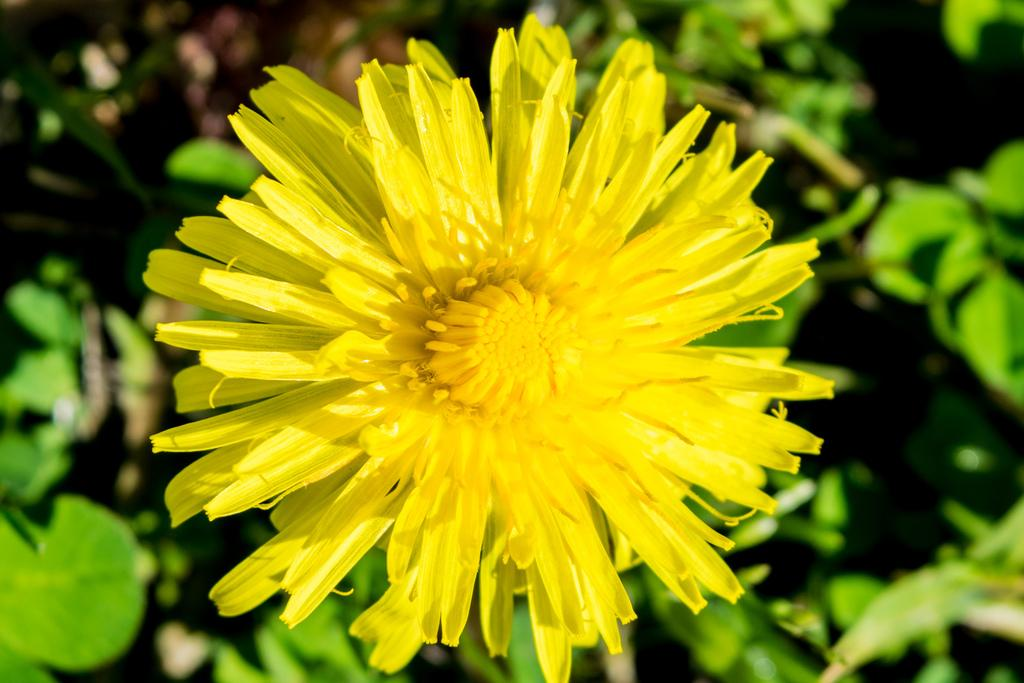What type of plant is in the picture? There is a flower plant in the picture. What color is the flower on the plant? The flower is yellow. How would you describe the background of the image? The background of the image is blurred. Can you see a toad sitting next to the flower in the image? There is no toad present in the image; it only features a flower plant with a yellow flower. 